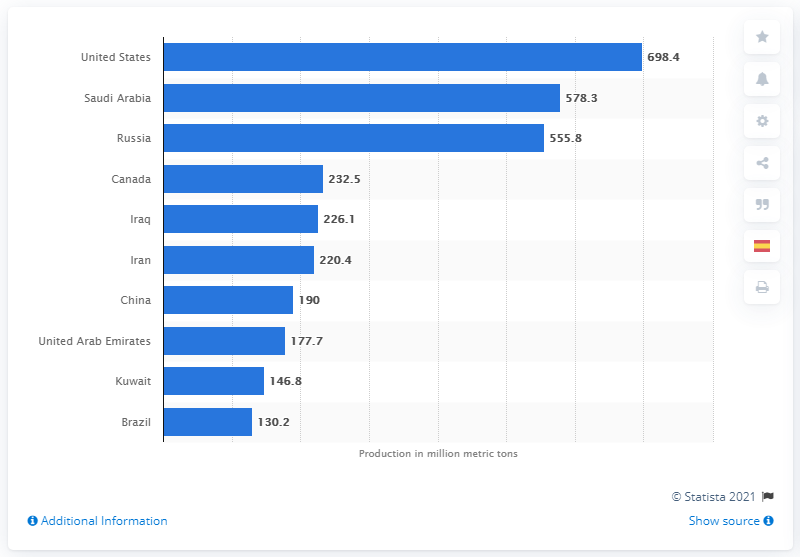List a handful of essential elements in this visual. In the year 2018, the United States produced a total of 698.4 barrels of oil. 